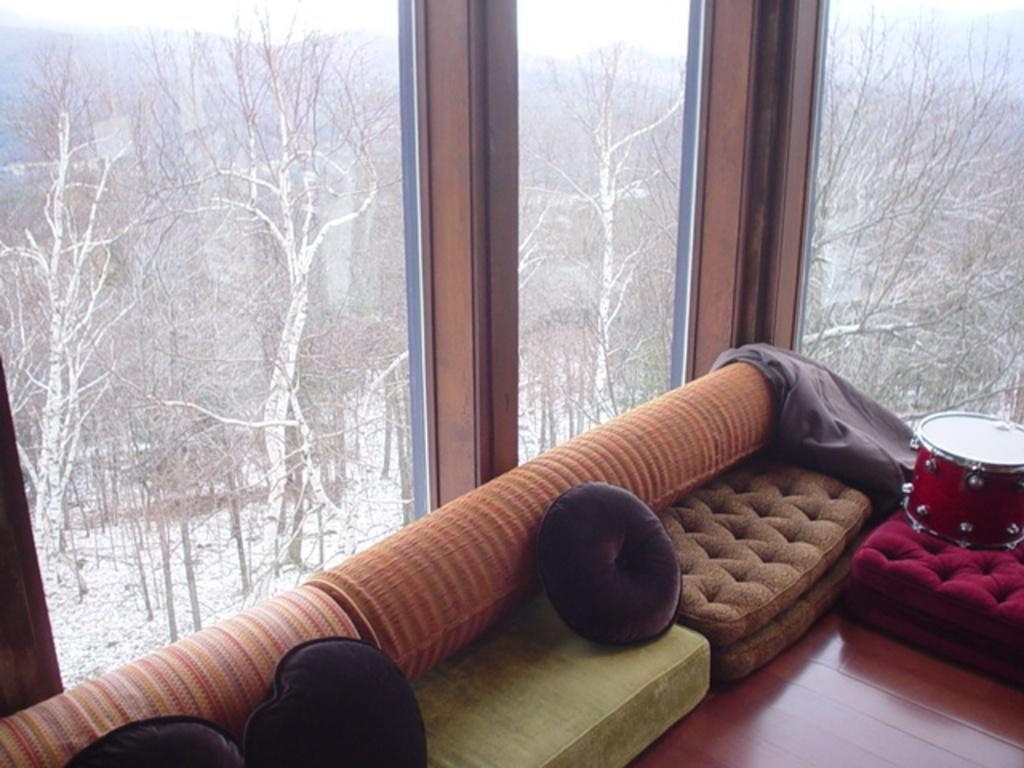What type of furniture is present in the image? There is a sofa set in the image. What other object can be seen in the image? There is a musical instrument in the image. What can be seen through the windows in the image? Snow is visible in the image. What type of natural features are present in the image? There are trees and hills in the image. What part of the natural environment is visible in the image? The sky is visible in the image. Where is the ant located in the image? There is no ant present in the image. What is the brother doing in the image? There is no brother present in the image. 